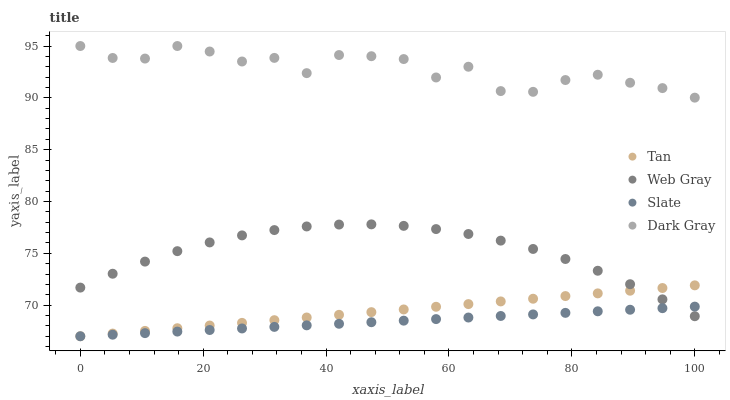Does Slate have the minimum area under the curve?
Answer yes or no. Yes. Does Dark Gray have the maximum area under the curve?
Answer yes or no. Yes. Does Tan have the minimum area under the curve?
Answer yes or no. No. Does Tan have the maximum area under the curve?
Answer yes or no. No. Is Slate the smoothest?
Answer yes or no. Yes. Is Dark Gray the roughest?
Answer yes or no. Yes. Is Tan the smoothest?
Answer yes or no. No. Is Tan the roughest?
Answer yes or no. No. Does Tan have the lowest value?
Answer yes or no. Yes. Does Web Gray have the lowest value?
Answer yes or no. No. Does Dark Gray have the highest value?
Answer yes or no. Yes. Does Tan have the highest value?
Answer yes or no. No. Is Tan less than Dark Gray?
Answer yes or no. Yes. Is Dark Gray greater than Web Gray?
Answer yes or no. Yes. Does Web Gray intersect Slate?
Answer yes or no. Yes. Is Web Gray less than Slate?
Answer yes or no. No. Is Web Gray greater than Slate?
Answer yes or no. No. Does Tan intersect Dark Gray?
Answer yes or no. No. 